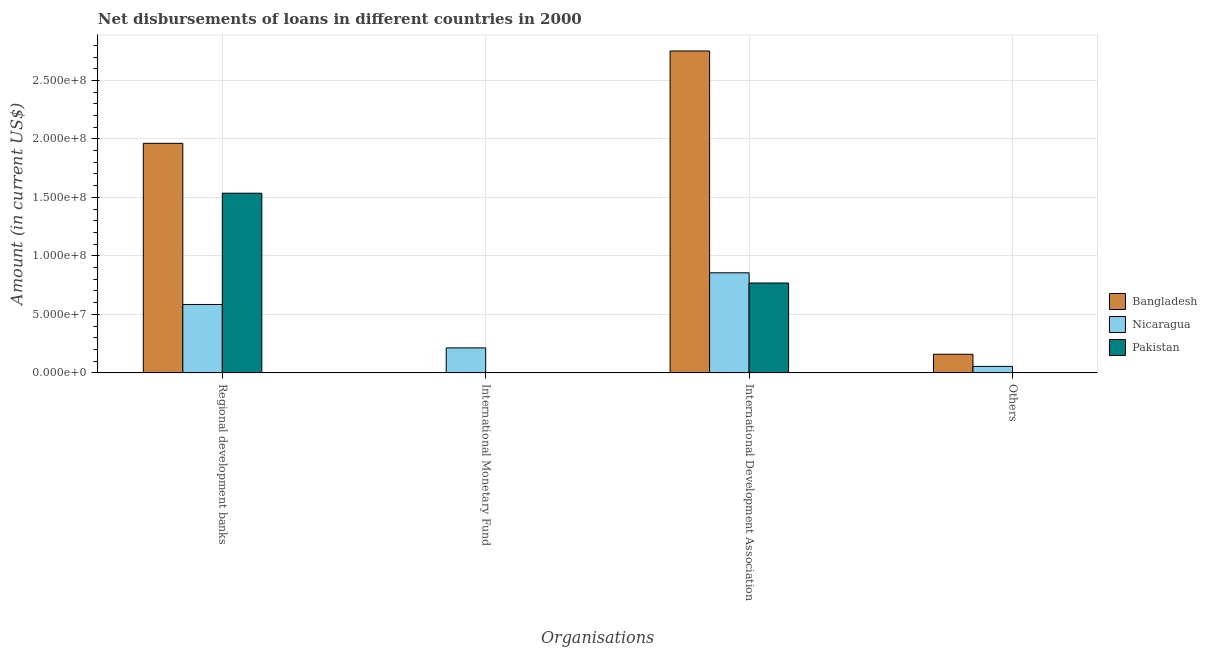How many bars are there on the 2nd tick from the left?
Your response must be concise. 1. How many bars are there on the 2nd tick from the right?
Offer a very short reply. 3. What is the label of the 2nd group of bars from the left?
Give a very brief answer. International Monetary Fund. What is the amount of loan disimbursed by international monetary fund in Nicaragua?
Give a very brief answer. 2.13e+07. Across all countries, what is the maximum amount of loan disimbursed by other organisations?
Your answer should be compact. 1.59e+07. Across all countries, what is the minimum amount of loan disimbursed by regional development banks?
Provide a succinct answer. 5.85e+07. In which country was the amount of loan disimbursed by international development association maximum?
Your answer should be very brief. Bangladesh. What is the total amount of loan disimbursed by international monetary fund in the graph?
Offer a very short reply. 2.13e+07. What is the difference between the amount of loan disimbursed by regional development banks in Nicaragua and that in Bangladesh?
Offer a very short reply. -1.38e+08. What is the difference between the amount of loan disimbursed by other organisations in Nicaragua and the amount of loan disimbursed by international monetary fund in Bangladesh?
Your answer should be very brief. 5.53e+06. What is the average amount of loan disimbursed by regional development banks per country?
Ensure brevity in your answer.  1.36e+08. What is the difference between the amount of loan disimbursed by other organisations and amount of loan disimbursed by international development association in Bangladesh?
Provide a succinct answer. -2.59e+08. In how many countries, is the amount of loan disimbursed by international monetary fund greater than 270000000 US$?
Offer a very short reply. 0. What is the ratio of the amount of loan disimbursed by other organisations in Bangladesh to that in Nicaragua?
Provide a succinct answer. 2.88. Is the amount of loan disimbursed by regional development banks in Nicaragua less than that in Bangladesh?
Your response must be concise. Yes. What is the difference between the highest and the second highest amount of loan disimbursed by regional development banks?
Keep it short and to the point. 4.26e+07. What is the difference between the highest and the lowest amount of loan disimbursed by other organisations?
Offer a terse response. 1.59e+07. In how many countries, is the amount of loan disimbursed by regional development banks greater than the average amount of loan disimbursed by regional development banks taken over all countries?
Your answer should be very brief. 2. Is it the case that in every country, the sum of the amount of loan disimbursed by regional development banks and amount of loan disimbursed by international monetary fund is greater than the amount of loan disimbursed by international development association?
Give a very brief answer. No. How many bars are there?
Your response must be concise. 9. What is the difference between two consecutive major ticks on the Y-axis?
Provide a short and direct response. 5.00e+07. Are the values on the major ticks of Y-axis written in scientific E-notation?
Give a very brief answer. Yes. Does the graph contain any zero values?
Your answer should be compact. Yes. What is the title of the graph?
Keep it short and to the point. Net disbursements of loans in different countries in 2000. What is the label or title of the X-axis?
Offer a very short reply. Organisations. What is the label or title of the Y-axis?
Keep it short and to the point. Amount (in current US$). What is the Amount (in current US$) of Bangladesh in Regional development banks?
Your response must be concise. 1.96e+08. What is the Amount (in current US$) in Nicaragua in Regional development banks?
Offer a very short reply. 5.85e+07. What is the Amount (in current US$) in Pakistan in Regional development banks?
Your answer should be very brief. 1.54e+08. What is the Amount (in current US$) in Nicaragua in International Monetary Fund?
Give a very brief answer. 2.13e+07. What is the Amount (in current US$) of Bangladesh in International Development Association?
Offer a terse response. 2.75e+08. What is the Amount (in current US$) in Nicaragua in International Development Association?
Provide a short and direct response. 8.55e+07. What is the Amount (in current US$) in Pakistan in International Development Association?
Make the answer very short. 7.68e+07. What is the Amount (in current US$) of Bangladesh in Others?
Ensure brevity in your answer.  1.59e+07. What is the Amount (in current US$) in Nicaragua in Others?
Your response must be concise. 5.53e+06. What is the Amount (in current US$) in Pakistan in Others?
Give a very brief answer. 0. Across all Organisations, what is the maximum Amount (in current US$) of Bangladesh?
Offer a very short reply. 2.75e+08. Across all Organisations, what is the maximum Amount (in current US$) in Nicaragua?
Your answer should be very brief. 8.55e+07. Across all Organisations, what is the maximum Amount (in current US$) in Pakistan?
Your response must be concise. 1.54e+08. Across all Organisations, what is the minimum Amount (in current US$) of Nicaragua?
Your answer should be very brief. 5.53e+06. Across all Organisations, what is the minimum Amount (in current US$) in Pakistan?
Provide a short and direct response. 0. What is the total Amount (in current US$) of Bangladesh in the graph?
Provide a short and direct response. 4.87e+08. What is the total Amount (in current US$) of Nicaragua in the graph?
Make the answer very short. 1.71e+08. What is the total Amount (in current US$) in Pakistan in the graph?
Give a very brief answer. 2.30e+08. What is the difference between the Amount (in current US$) of Nicaragua in Regional development banks and that in International Monetary Fund?
Your answer should be compact. 3.71e+07. What is the difference between the Amount (in current US$) of Bangladesh in Regional development banks and that in International Development Association?
Make the answer very short. -7.90e+07. What is the difference between the Amount (in current US$) of Nicaragua in Regional development banks and that in International Development Association?
Provide a short and direct response. -2.71e+07. What is the difference between the Amount (in current US$) of Pakistan in Regional development banks and that in International Development Association?
Provide a succinct answer. 7.68e+07. What is the difference between the Amount (in current US$) in Bangladesh in Regional development banks and that in Others?
Give a very brief answer. 1.80e+08. What is the difference between the Amount (in current US$) of Nicaragua in Regional development banks and that in Others?
Keep it short and to the point. 5.29e+07. What is the difference between the Amount (in current US$) of Nicaragua in International Monetary Fund and that in International Development Association?
Offer a terse response. -6.42e+07. What is the difference between the Amount (in current US$) of Nicaragua in International Monetary Fund and that in Others?
Give a very brief answer. 1.58e+07. What is the difference between the Amount (in current US$) of Bangladesh in International Development Association and that in Others?
Provide a short and direct response. 2.59e+08. What is the difference between the Amount (in current US$) in Nicaragua in International Development Association and that in Others?
Provide a short and direct response. 8.00e+07. What is the difference between the Amount (in current US$) in Bangladesh in Regional development banks and the Amount (in current US$) in Nicaragua in International Monetary Fund?
Offer a very short reply. 1.75e+08. What is the difference between the Amount (in current US$) in Bangladesh in Regional development banks and the Amount (in current US$) in Nicaragua in International Development Association?
Provide a succinct answer. 1.11e+08. What is the difference between the Amount (in current US$) in Bangladesh in Regional development banks and the Amount (in current US$) in Pakistan in International Development Association?
Keep it short and to the point. 1.19e+08. What is the difference between the Amount (in current US$) of Nicaragua in Regional development banks and the Amount (in current US$) of Pakistan in International Development Association?
Your response must be concise. -1.83e+07. What is the difference between the Amount (in current US$) of Bangladesh in Regional development banks and the Amount (in current US$) of Nicaragua in Others?
Your answer should be compact. 1.91e+08. What is the difference between the Amount (in current US$) of Nicaragua in International Monetary Fund and the Amount (in current US$) of Pakistan in International Development Association?
Your answer should be very brief. -5.55e+07. What is the difference between the Amount (in current US$) in Bangladesh in International Development Association and the Amount (in current US$) in Nicaragua in Others?
Your answer should be compact. 2.70e+08. What is the average Amount (in current US$) in Bangladesh per Organisations?
Make the answer very short. 1.22e+08. What is the average Amount (in current US$) of Nicaragua per Organisations?
Offer a very short reply. 4.27e+07. What is the average Amount (in current US$) of Pakistan per Organisations?
Provide a succinct answer. 5.76e+07. What is the difference between the Amount (in current US$) in Bangladesh and Amount (in current US$) in Nicaragua in Regional development banks?
Offer a terse response. 1.38e+08. What is the difference between the Amount (in current US$) in Bangladesh and Amount (in current US$) in Pakistan in Regional development banks?
Provide a short and direct response. 4.26e+07. What is the difference between the Amount (in current US$) of Nicaragua and Amount (in current US$) of Pakistan in Regional development banks?
Ensure brevity in your answer.  -9.51e+07. What is the difference between the Amount (in current US$) in Bangladesh and Amount (in current US$) in Nicaragua in International Development Association?
Keep it short and to the point. 1.90e+08. What is the difference between the Amount (in current US$) in Bangladesh and Amount (in current US$) in Pakistan in International Development Association?
Make the answer very short. 1.98e+08. What is the difference between the Amount (in current US$) of Nicaragua and Amount (in current US$) of Pakistan in International Development Association?
Ensure brevity in your answer.  8.72e+06. What is the difference between the Amount (in current US$) in Bangladesh and Amount (in current US$) in Nicaragua in Others?
Your response must be concise. 1.04e+07. What is the ratio of the Amount (in current US$) in Nicaragua in Regional development banks to that in International Monetary Fund?
Your response must be concise. 2.74. What is the ratio of the Amount (in current US$) of Bangladesh in Regional development banks to that in International Development Association?
Offer a terse response. 0.71. What is the ratio of the Amount (in current US$) in Nicaragua in Regional development banks to that in International Development Association?
Offer a terse response. 0.68. What is the ratio of the Amount (in current US$) in Pakistan in Regional development banks to that in International Development Association?
Provide a short and direct response. 2. What is the ratio of the Amount (in current US$) in Bangladesh in Regional development banks to that in Others?
Keep it short and to the point. 12.33. What is the ratio of the Amount (in current US$) in Nicaragua in Regional development banks to that in Others?
Make the answer very short. 10.57. What is the ratio of the Amount (in current US$) of Nicaragua in International Monetary Fund to that in International Development Association?
Ensure brevity in your answer.  0.25. What is the ratio of the Amount (in current US$) of Nicaragua in International Monetary Fund to that in Others?
Ensure brevity in your answer.  3.86. What is the ratio of the Amount (in current US$) in Bangladesh in International Development Association to that in Others?
Offer a terse response. 17.29. What is the ratio of the Amount (in current US$) of Nicaragua in International Development Association to that in Others?
Keep it short and to the point. 15.47. What is the difference between the highest and the second highest Amount (in current US$) in Bangladesh?
Provide a short and direct response. 7.90e+07. What is the difference between the highest and the second highest Amount (in current US$) in Nicaragua?
Make the answer very short. 2.71e+07. What is the difference between the highest and the lowest Amount (in current US$) of Bangladesh?
Offer a terse response. 2.75e+08. What is the difference between the highest and the lowest Amount (in current US$) in Nicaragua?
Provide a succinct answer. 8.00e+07. What is the difference between the highest and the lowest Amount (in current US$) in Pakistan?
Keep it short and to the point. 1.54e+08. 